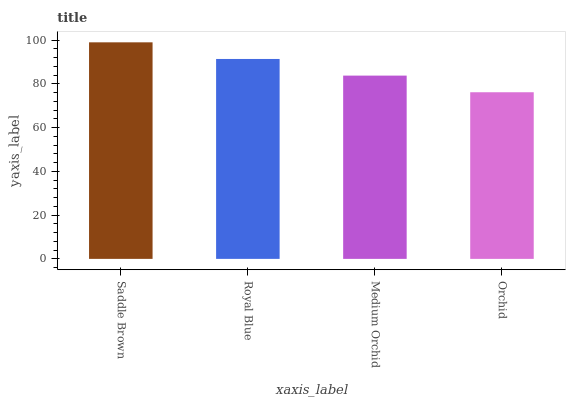Is Orchid the minimum?
Answer yes or no. Yes. Is Saddle Brown the maximum?
Answer yes or no. Yes. Is Royal Blue the minimum?
Answer yes or no. No. Is Royal Blue the maximum?
Answer yes or no. No. Is Saddle Brown greater than Royal Blue?
Answer yes or no. Yes. Is Royal Blue less than Saddle Brown?
Answer yes or no. Yes. Is Royal Blue greater than Saddle Brown?
Answer yes or no. No. Is Saddle Brown less than Royal Blue?
Answer yes or no. No. Is Royal Blue the high median?
Answer yes or no. Yes. Is Medium Orchid the low median?
Answer yes or no. Yes. Is Medium Orchid the high median?
Answer yes or no. No. Is Saddle Brown the low median?
Answer yes or no. No. 